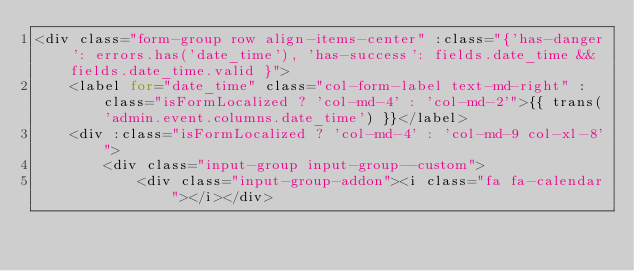Convert code to text. <code><loc_0><loc_0><loc_500><loc_500><_PHP_><div class="form-group row align-items-center" :class="{'has-danger': errors.has('date_time'), 'has-success': fields.date_time && fields.date_time.valid }">
    <label for="date_time" class="col-form-label text-md-right" :class="isFormLocalized ? 'col-md-4' : 'col-md-2'">{{ trans('admin.event.columns.date_time') }}</label>
    <div :class="isFormLocalized ? 'col-md-4' : 'col-md-9 col-xl-8'">
        <div class="input-group input-group--custom">
            <div class="input-group-addon"><i class="fa fa-calendar"></i></div></code> 